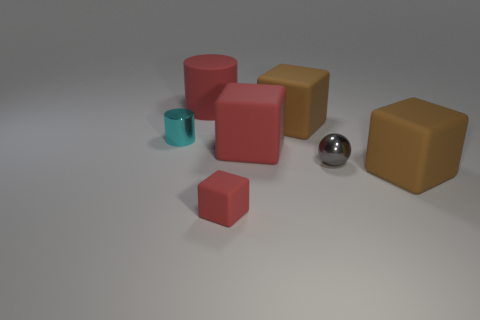What shape is the large thing that is the same color as the rubber cylinder?
Keep it short and to the point. Cube. What number of big brown rubber things are the same shape as the tiny gray metallic object?
Keep it short and to the point. 0. The red block in front of the brown rubber thing that is in front of the tiny cyan metallic object is made of what material?
Ensure brevity in your answer.  Rubber. There is a matte thing that is to the right of the tiny gray metallic sphere; what size is it?
Your answer should be very brief. Large. How many cyan things are either shiny objects or tiny blocks?
Provide a short and direct response. 1. Is there any other thing that is the same material as the tiny ball?
Offer a terse response. Yes. What is the material of the large red thing that is the same shape as the small red rubber thing?
Ensure brevity in your answer.  Rubber. Are there the same number of red blocks that are in front of the cyan metallic cylinder and brown cubes?
Your response must be concise. Yes. What size is the thing that is both left of the large red matte cube and in front of the small gray metal object?
Your answer should be very brief. Small. Is there any other thing of the same color as the metal ball?
Offer a very short reply. No. 